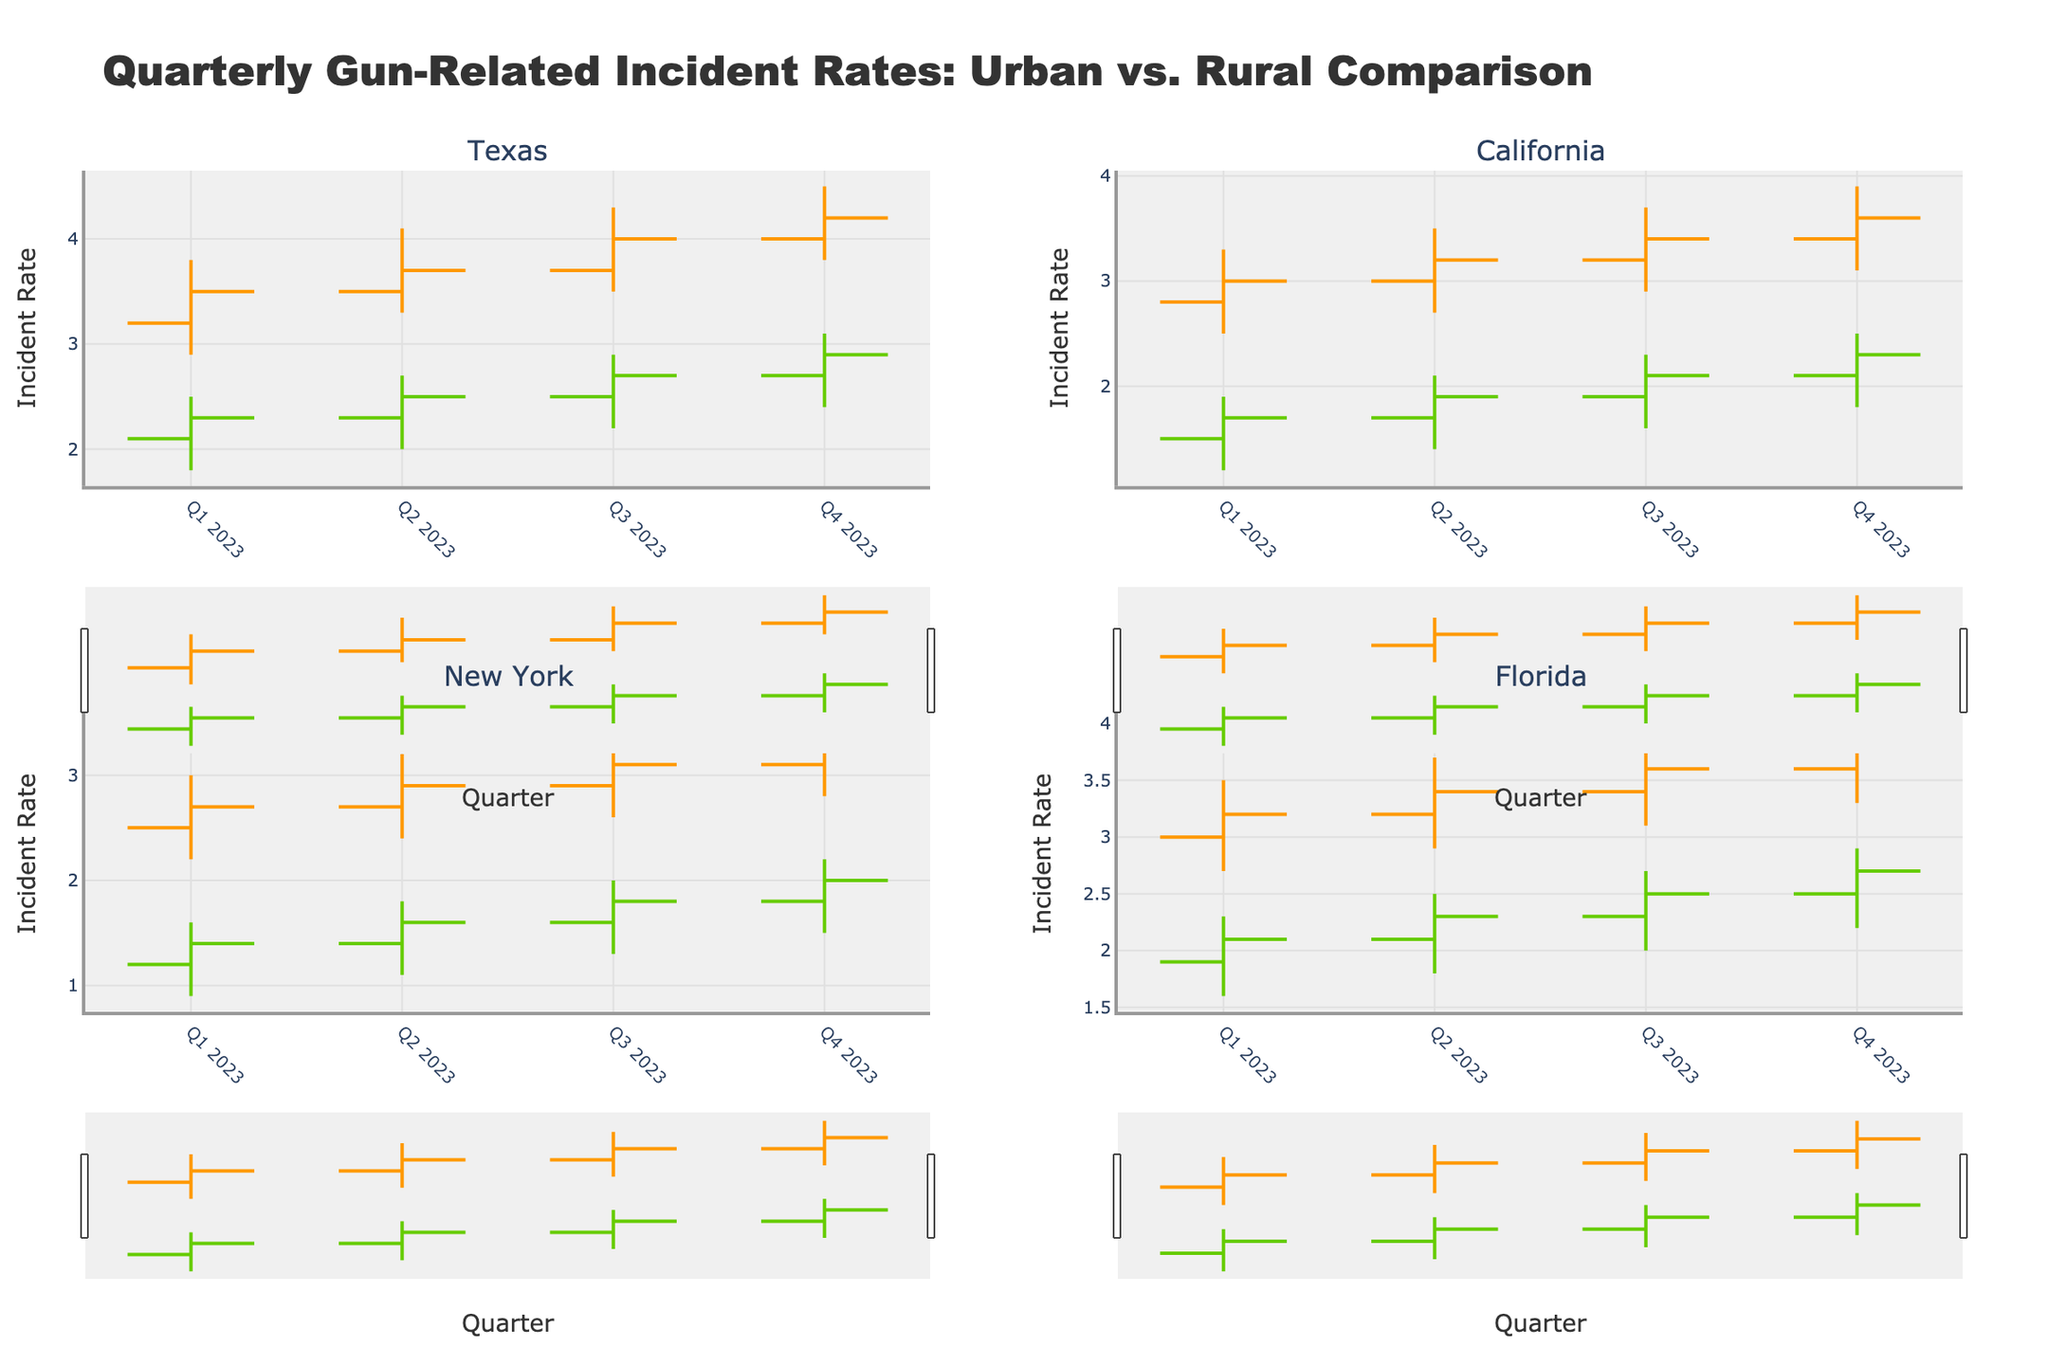Which state has the highest Urban gun-related incident rate in Q4 2023? Check California, New York, Florida, and Texas in Q4 2023 for Urban incident rates and compare their highest values (Urban_High). Texas has the highest at 4.5.
Answer: Texas What is the difference in Rural gun-related incident rates between Q1 and Q4 2023 in New York? Look at New York's Rural incident rates for Q1 and Q4 2023. The values are 1.6 and 2.2, respectively. Calculate the difference: 2.2 - 1.6 = 0.6.
Answer: 0.6 Calculate the average Urban incident rate in California for the first two quarters of 2023. For California, look at Urban_Close rates for Q1 and Q2 2023. The values are 3.0 and 3.2. Compute the average: (3.0 + 3.2) / 2 = 3.1.
Answer: 3.1 How does the urban incident rate in Texas in Q2 2023 compare to that in New York in Q2 2023? Compare the Urban_Close rate of Texas (3.7) and New York (2.9) in Q2 2023. Texas' rate is higher.
Answer: Texas has a higher rate Identify the quarter in which Florida's Rural incident rate first exceeded 2.0 in 2023. Look through Florida's Rural_Close rates in each quarter of 2023. The value first exceeds 2.0 in Q2 2023, which is 2.1.
Answer: Q2 2023 Was there any quarter where Urban incident rates for all states decreased compared to the previous quarter? Compare Urban_Close rates from one quarter to the next for all states:
- Texas: Q4 > Q3 > Q2 > Q1
- California: Q4 > Q3 > Q2 > Q1
- New York: Q4 > Q3 > Q2 > Q1
- Florida: Q4 > Q3 > Q2 > Q1
No, they have all increased in each subsequent quarter in 2023.
Answer: No Which state shows the smallest difference between Urban Open and Urban Close incident rates in any quarter of 2023? Calculate the difference between Urban Open and Urban Close for all states in each quarter. The smallest difference is in New York in Q2 2023 (2.7 - 2.9 = -0.2).
Answer: New York 